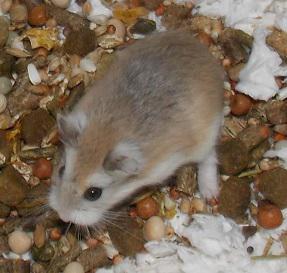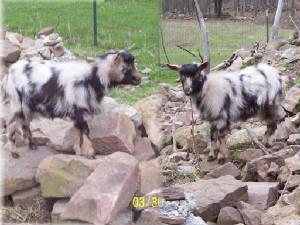The first image is the image on the left, the second image is the image on the right. Assess this claim about the two images: "There is exactly one rodent in the image on the left.". Correct or not? Answer yes or no. Yes. 